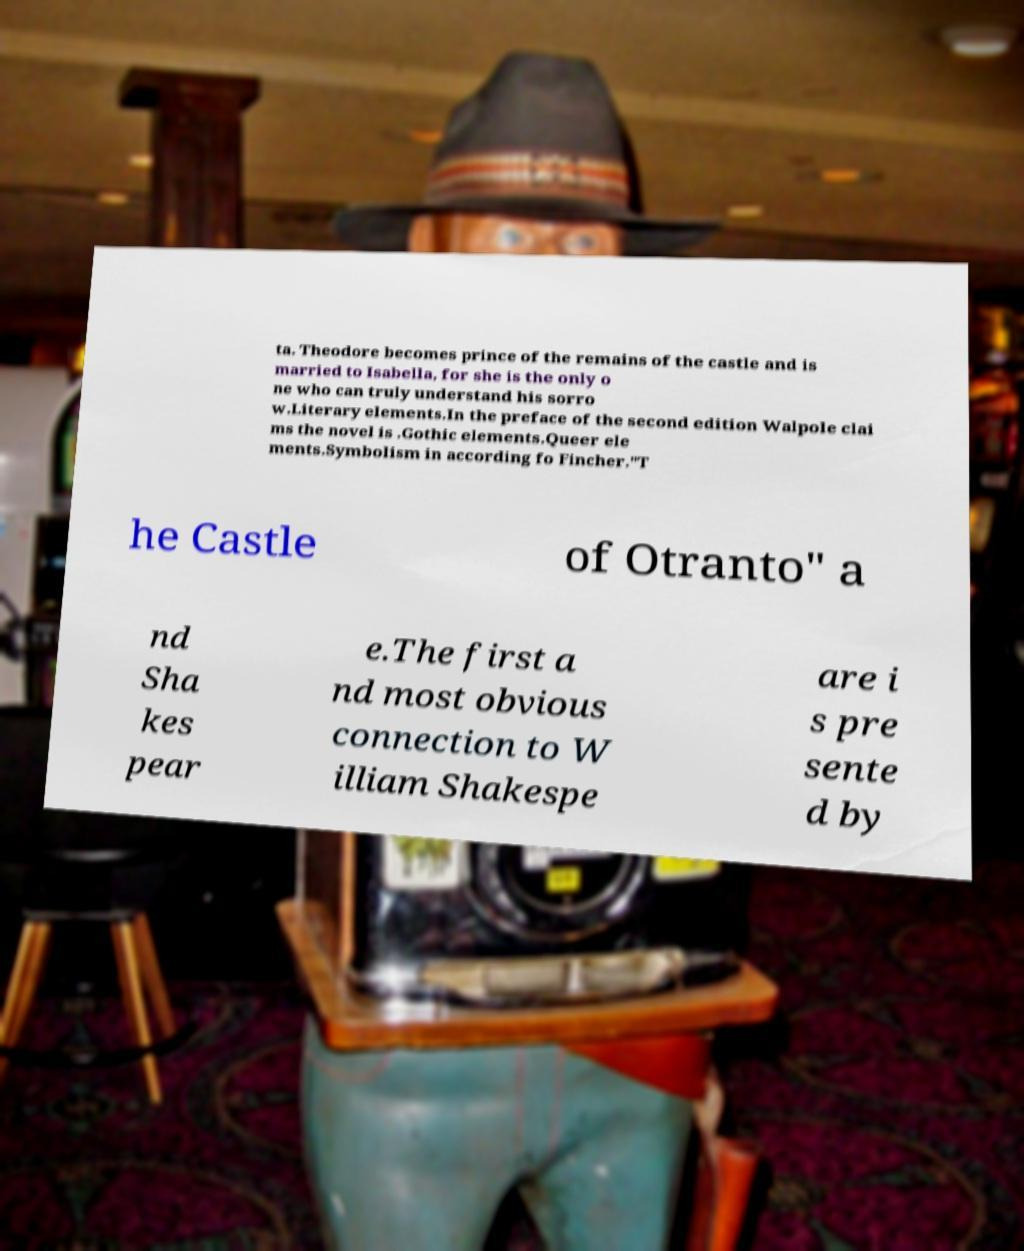Could you extract and type out the text from this image? ta. Theodore becomes prince of the remains of the castle and is married to Isabella, for she is the only o ne who can truly understand his sorro w.Literary elements.In the preface of the second edition Walpole clai ms the novel is .Gothic elements.Queer ele ments.Symbolism in according fo Fincher."T he Castle of Otranto" a nd Sha kes pear e.The first a nd most obvious connection to W illiam Shakespe are i s pre sente d by 